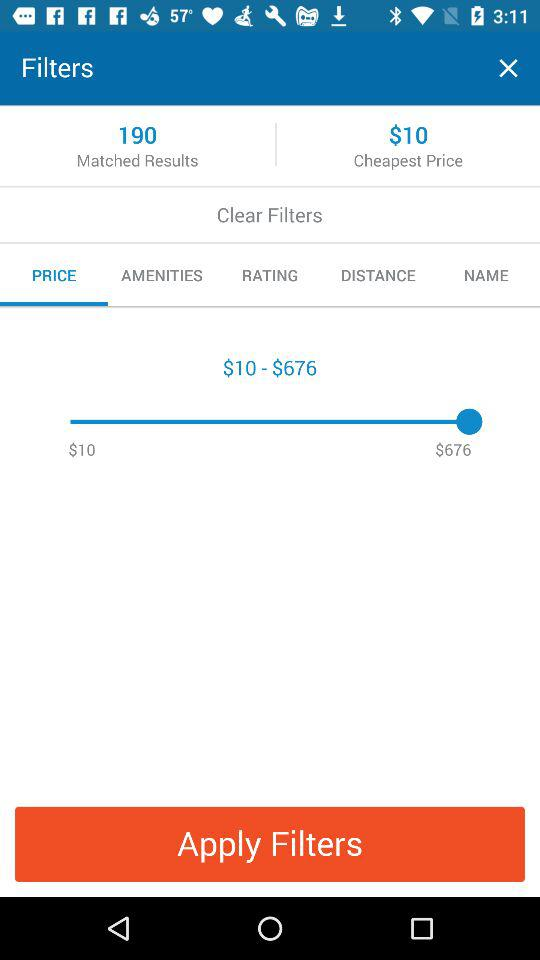What's the price range? The price range is $10–$676. 